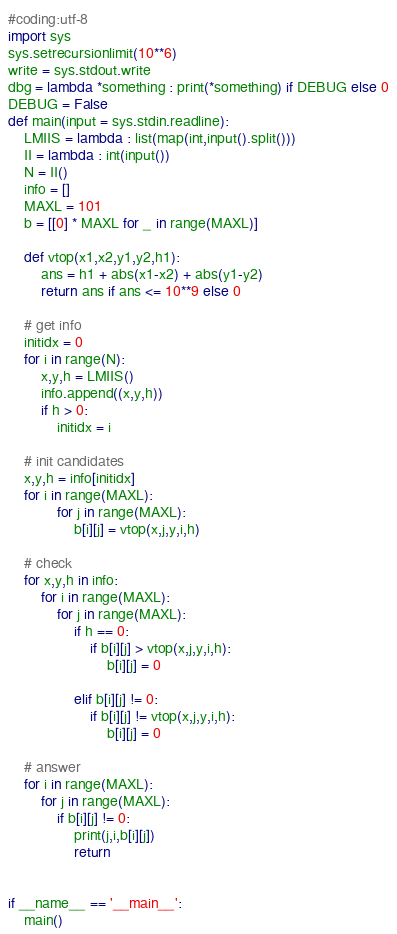Convert code to text. <code><loc_0><loc_0><loc_500><loc_500><_Python_>#coding:utf-8
import sys
sys.setrecursionlimit(10**6)
write = sys.stdout.write
dbg = lambda *something : print(*something) if DEBUG else 0
DEBUG = False
def main(input = sys.stdin.readline):
    LMIIS = lambda : list(map(int,input().split()))
    II = lambda : int(input())
    N = II()
    info = []
    MAXL = 101
    b = [[0] * MAXL for _ in range(MAXL)]

    def vtop(x1,x2,y1,y2,h1):
        ans = h1 + abs(x1-x2) + abs(y1-y2)
        return ans if ans <= 10**9 else 0

    # get info
    initidx = 0
    for i in range(N):
        x,y,h = LMIIS()
        info.append((x,y,h))
        if h > 0:
            initidx = i

    # init candidates
    x,y,h = info[initidx]
    for i in range(MAXL):
            for j in range(MAXL):
                b[i][j] = vtop(x,j,y,i,h)

    # check
    for x,y,h in info:
        for i in range(MAXL):
            for j in range(MAXL):
                if h == 0:
                    if b[i][j] > vtop(x,j,y,i,h):
                        b[i][j] = 0

                elif b[i][j] != 0:
                    if b[i][j] != vtop(x,j,y,i,h):
                        b[i][j] = 0

    # answer
    for i in range(MAXL):
        for j in range(MAXL):
            if b[i][j] != 0:
                print(j,i,b[i][j])
                return


if __name__ == '__main__':
    main()</code> 